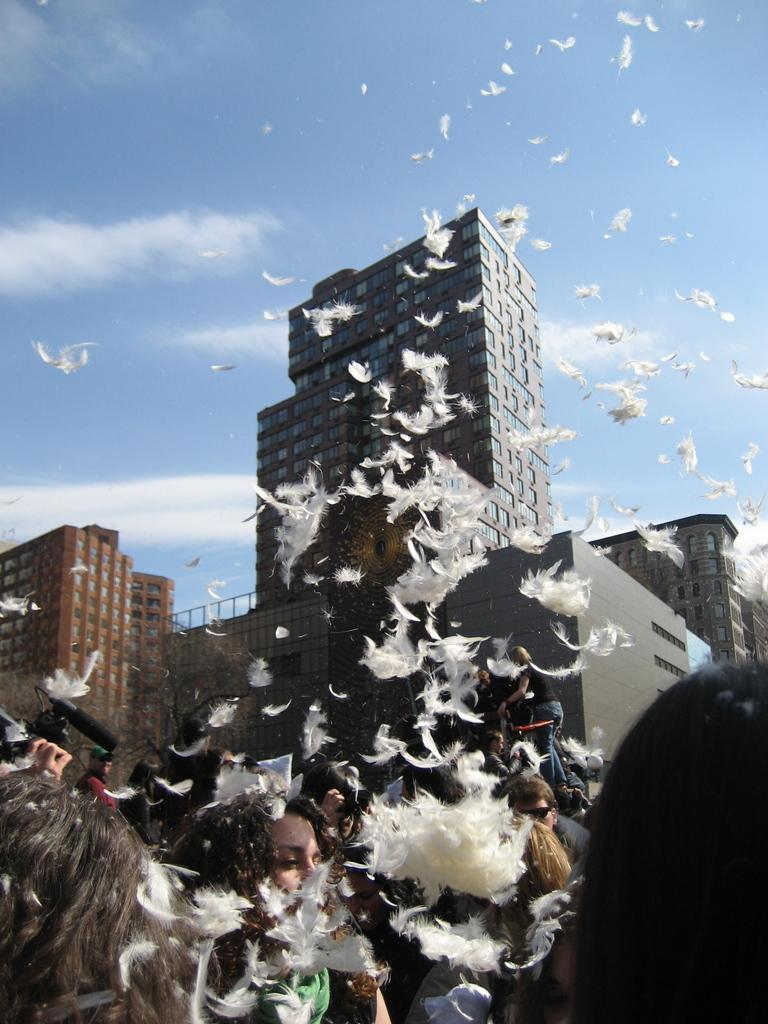What type of structures can be seen in the image? There are buildings in the image. Can you describe the people in the image? There are persons in the front bottom side of the image. What else is present in the air besides the buildings? There are white color bird feathers flying in the air. What book is the person reading in the image? There is no book present in the image; it only shows persons and bird feathers. What type of stitch is being used to create the effect of the bird feathers in the image? The image is a photograph, not a drawing or painting, so there is no stitching involved in creating the bird feathers. 